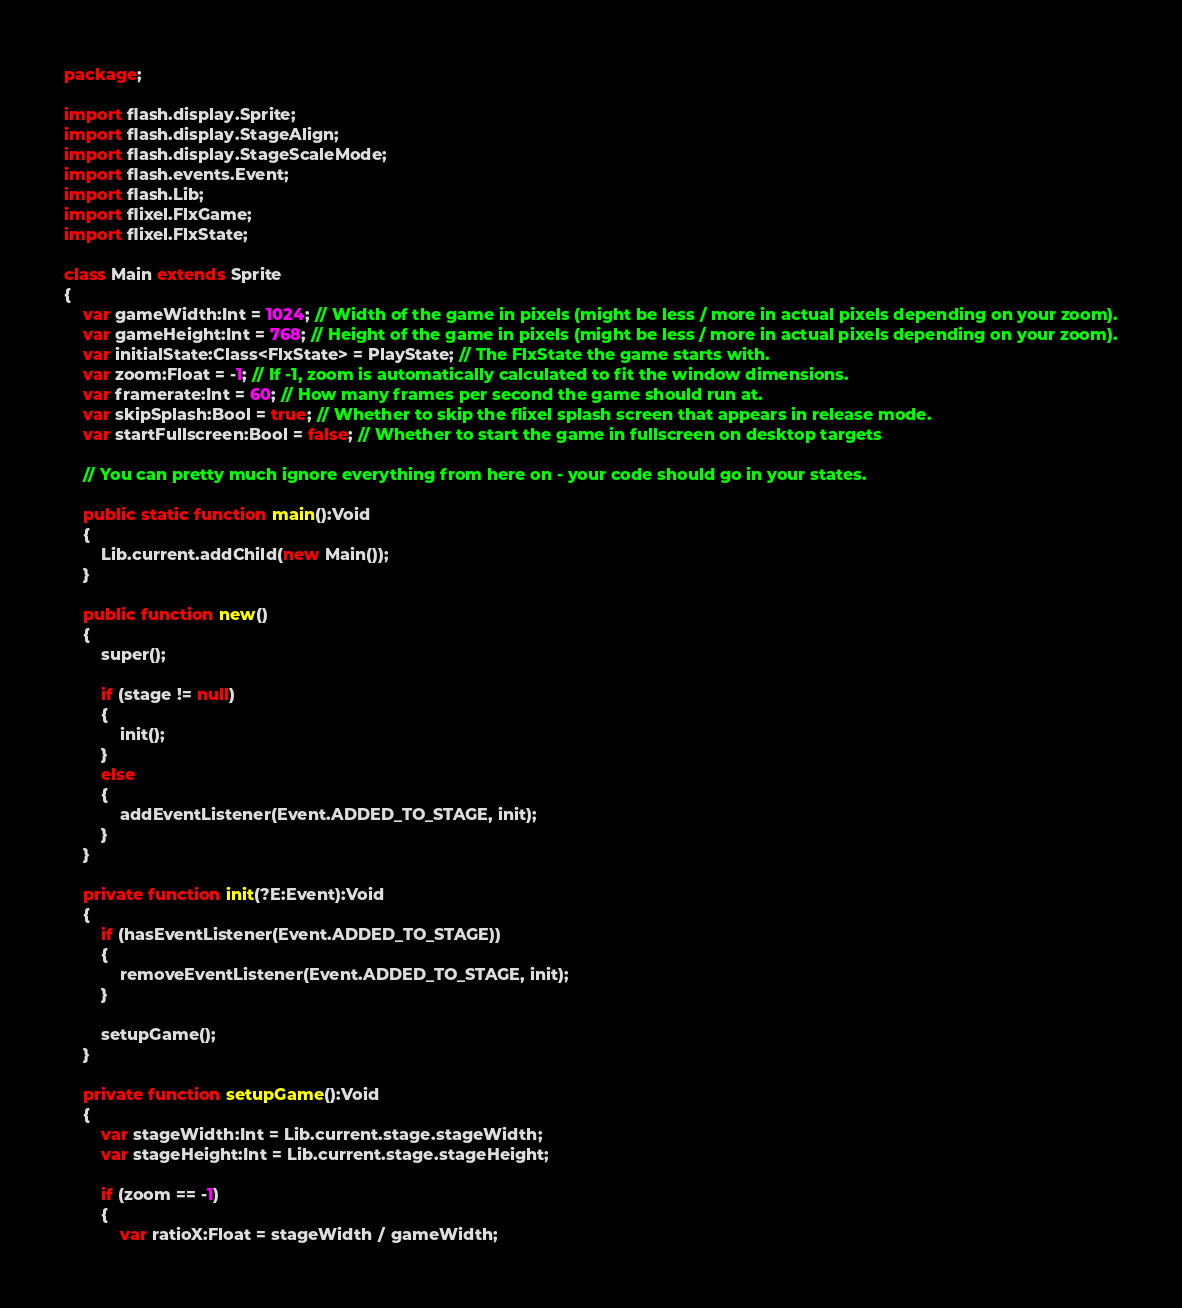Convert code to text. <code><loc_0><loc_0><loc_500><loc_500><_Haxe_>package;

import flash.display.Sprite;
import flash.display.StageAlign;
import flash.display.StageScaleMode;
import flash.events.Event;
import flash.Lib;
import flixel.FlxGame;
import flixel.FlxState;

class Main extends Sprite 
{
	var gameWidth:Int = 1024; // Width of the game in pixels (might be less / more in actual pixels depending on your zoom).
	var gameHeight:Int = 768; // Height of the game in pixels (might be less / more in actual pixels depending on your zoom).
	var initialState:Class<FlxState> = PlayState; // The FlxState the game starts with.
	var zoom:Float = -1; // If -1, zoom is automatically calculated to fit the window dimensions.
	var framerate:Int = 60; // How many frames per second the game should run at.
	var skipSplash:Bool = true; // Whether to skip the flixel splash screen that appears in release mode.
	var startFullscreen:Bool = false; // Whether to start the game in fullscreen on desktop targets
	
	// You can pretty much ignore everything from here on - your code should go in your states.
	
	public static function main():Void
	{	
		Lib.current.addChild(new Main());
	}
	
	public function new() 
	{
		super();
		
		if (stage != null) 
		{
			init();
		}
		else 
		{
			addEventListener(Event.ADDED_TO_STAGE, init);
		}
	}
	
	private function init(?E:Event):Void 
	{
		if (hasEventListener(Event.ADDED_TO_STAGE))
		{
			removeEventListener(Event.ADDED_TO_STAGE, init);
		}
		
		setupGame();
	}
	
	private function setupGame():Void
	{
		var stageWidth:Int = Lib.current.stage.stageWidth;
		var stageHeight:Int = Lib.current.stage.stageHeight;

		if (zoom == -1)
		{
			var ratioX:Float = stageWidth / gameWidth;</code> 